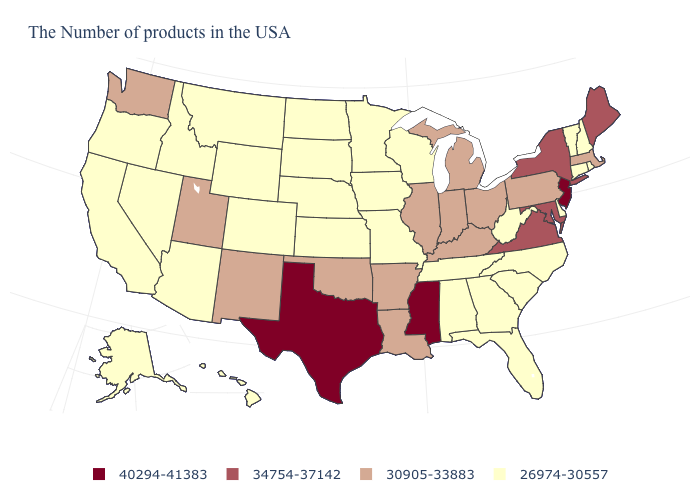Name the states that have a value in the range 30905-33883?
Short answer required. Massachusetts, Pennsylvania, Ohio, Michigan, Kentucky, Indiana, Illinois, Louisiana, Arkansas, Oklahoma, New Mexico, Utah, Washington. Name the states that have a value in the range 26974-30557?
Concise answer only. Rhode Island, New Hampshire, Vermont, Connecticut, Delaware, North Carolina, South Carolina, West Virginia, Florida, Georgia, Alabama, Tennessee, Wisconsin, Missouri, Minnesota, Iowa, Kansas, Nebraska, South Dakota, North Dakota, Wyoming, Colorado, Montana, Arizona, Idaho, Nevada, California, Oregon, Alaska, Hawaii. Name the states that have a value in the range 30905-33883?
Short answer required. Massachusetts, Pennsylvania, Ohio, Michigan, Kentucky, Indiana, Illinois, Louisiana, Arkansas, Oklahoma, New Mexico, Utah, Washington. Does Missouri have the same value as Colorado?
Keep it brief. Yes. Name the states that have a value in the range 34754-37142?
Be succinct. Maine, New York, Maryland, Virginia. What is the lowest value in states that border Michigan?
Give a very brief answer. 26974-30557. Is the legend a continuous bar?
Give a very brief answer. No. Name the states that have a value in the range 26974-30557?
Write a very short answer. Rhode Island, New Hampshire, Vermont, Connecticut, Delaware, North Carolina, South Carolina, West Virginia, Florida, Georgia, Alabama, Tennessee, Wisconsin, Missouri, Minnesota, Iowa, Kansas, Nebraska, South Dakota, North Dakota, Wyoming, Colorado, Montana, Arizona, Idaho, Nevada, California, Oregon, Alaska, Hawaii. Among the states that border West Virginia , does Maryland have the lowest value?
Keep it brief. No. Name the states that have a value in the range 26974-30557?
Short answer required. Rhode Island, New Hampshire, Vermont, Connecticut, Delaware, North Carolina, South Carolina, West Virginia, Florida, Georgia, Alabama, Tennessee, Wisconsin, Missouri, Minnesota, Iowa, Kansas, Nebraska, South Dakota, North Dakota, Wyoming, Colorado, Montana, Arizona, Idaho, Nevada, California, Oregon, Alaska, Hawaii. Does Michigan have a higher value than South Carolina?
Concise answer only. Yes. Does the map have missing data?
Write a very short answer. No. Does West Virginia have a lower value than Mississippi?
Concise answer only. Yes. Name the states that have a value in the range 26974-30557?
Give a very brief answer. Rhode Island, New Hampshire, Vermont, Connecticut, Delaware, North Carolina, South Carolina, West Virginia, Florida, Georgia, Alabama, Tennessee, Wisconsin, Missouri, Minnesota, Iowa, Kansas, Nebraska, South Dakota, North Dakota, Wyoming, Colorado, Montana, Arizona, Idaho, Nevada, California, Oregon, Alaska, Hawaii. What is the lowest value in the USA?
Quick response, please. 26974-30557. 